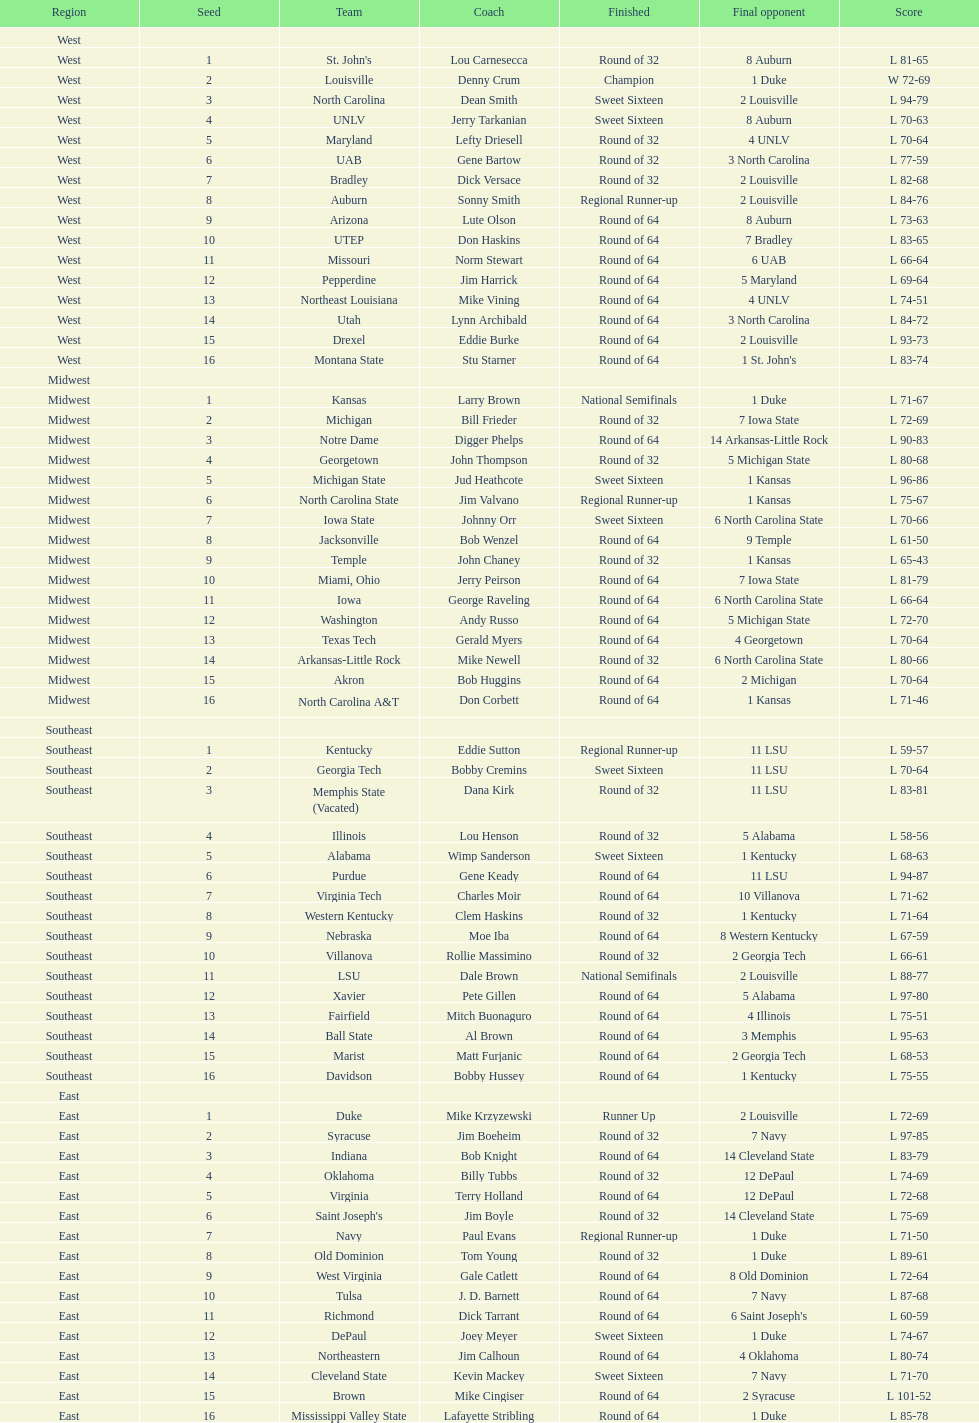What's the total count of teams in the east region? 16. 